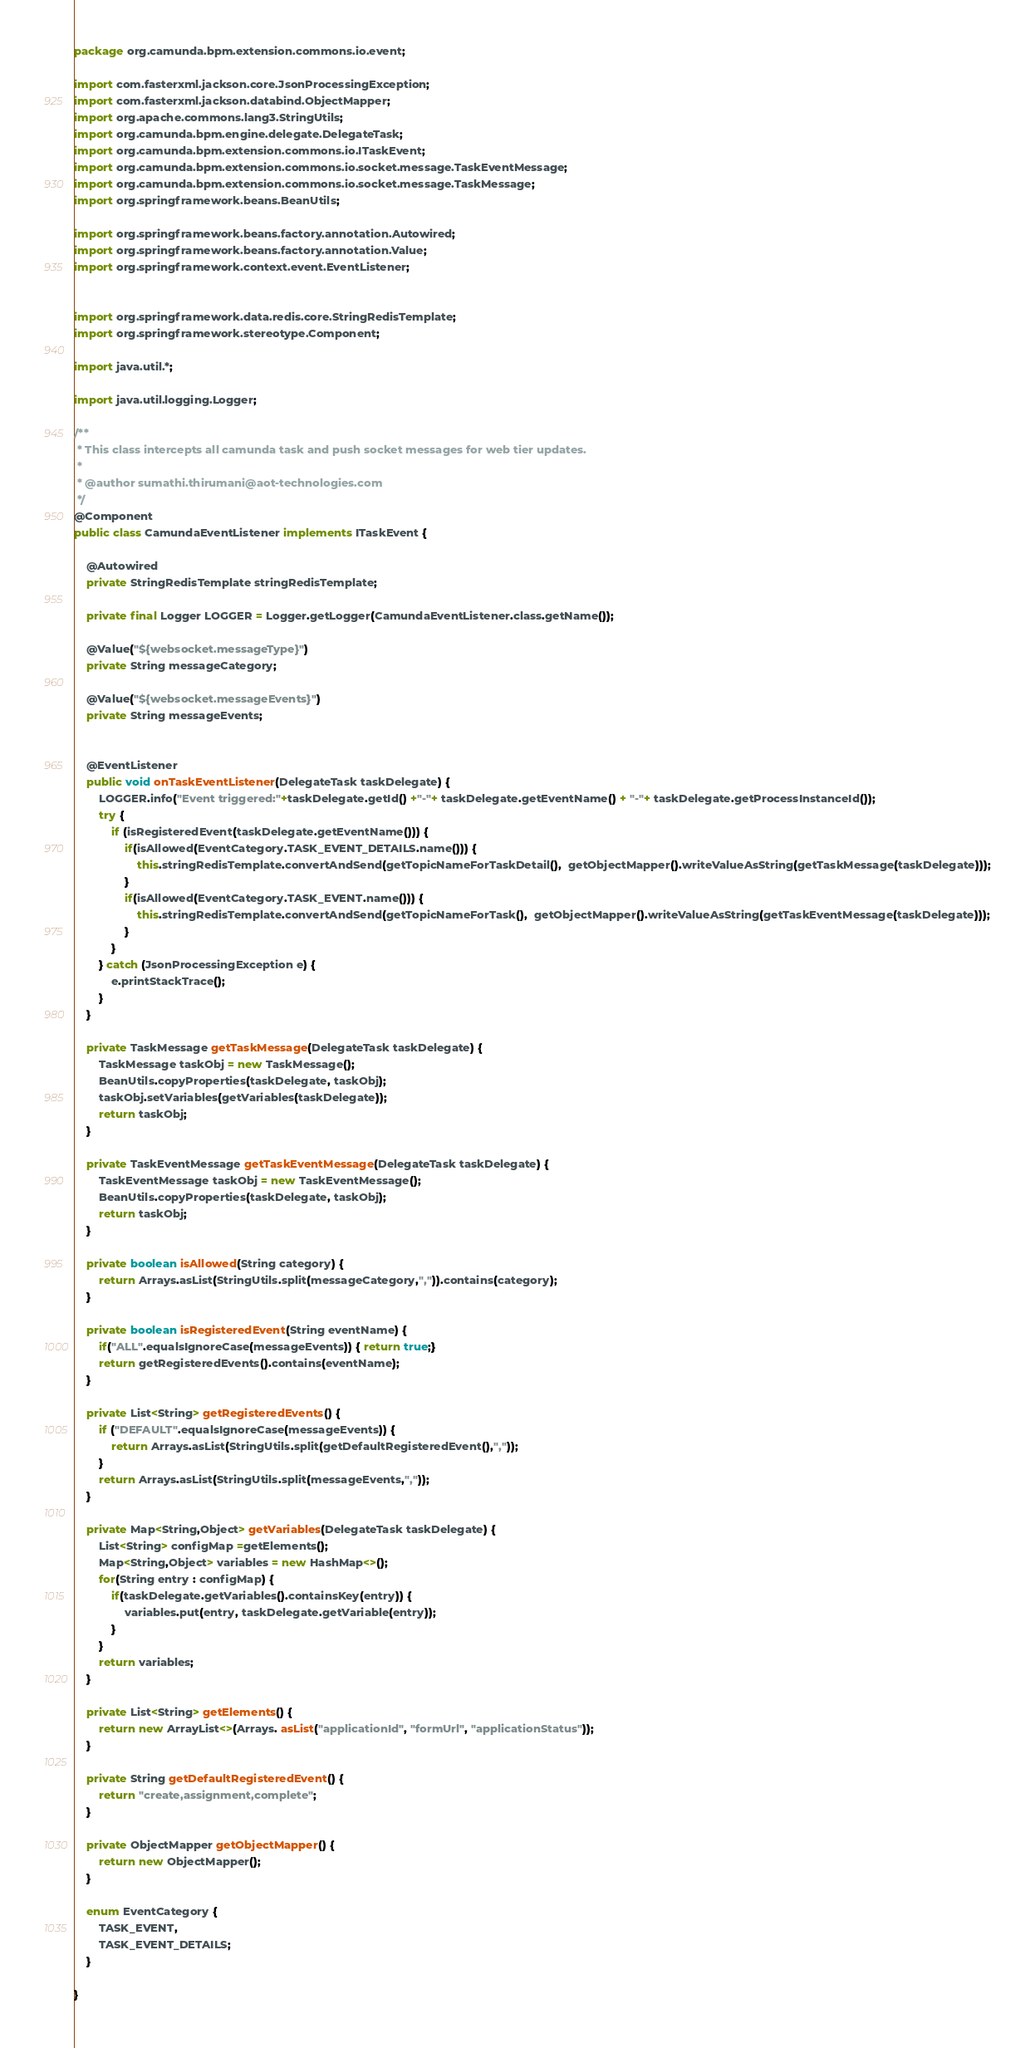<code> <loc_0><loc_0><loc_500><loc_500><_Java_>package org.camunda.bpm.extension.commons.io.event;

import com.fasterxml.jackson.core.JsonProcessingException;
import com.fasterxml.jackson.databind.ObjectMapper;
import org.apache.commons.lang3.StringUtils;
import org.camunda.bpm.engine.delegate.DelegateTask;
import org.camunda.bpm.extension.commons.io.ITaskEvent;
import org.camunda.bpm.extension.commons.io.socket.message.TaskEventMessage;
import org.camunda.bpm.extension.commons.io.socket.message.TaskMessage;
import org.springframework.beans.BeanUtils;

import org.springframework.beans.factory.annotation.Autowired;
import org.springframework.beans.factory.annotation.Value;
import org.springframework.context.event.EventListener;


import org.springframework.data.redis.core.StringRedisTemplate;
import org.springframework.stereotype.Component;

import java.util.*;

import java.util.logging.Logger;

/**
 * This class intercepts all camunda task and push socket messages for web tier updates.
 *
 * @author sumathi.thirumani@aot-technologies.com
 */
@Component
public class CamundaEventListener implements ITaskEvent {

    @Autowired
    private StringRedisTemplate stringRedisTemplate;

    private final Logger LOGGER = Logger.getLogger(CamundaEventListener.class.getName());

    @Value("${websocket.messageType}")
    private String messageCategory;
	
	@Value("${websocket.messageEvents}")
    private String messageEvents;


    @EventListener
    public void onTaskEventListener(DelegateTask taskDelegate) {
        LOGGER.info("Event triggered:"+taskDelegate.getId() +"-"+ taskDelegate.getEventName() + "-"+ taskDelegate.getProcessInstanceId());
        try {
			if (isRegisteredEvent(taskDelegate.getEventName())) {
				if(isAllowed(EventCategory.TASK_EVENT_DETAILS.name())) {
					this.stringRedisTemplate.convertAndSend(getTopicNameForTaskDetail(),  getObjectMapper().writeValueAsString(getTaskMessage(taskDelegate)));
				}
				if(isAllowed(EventCategory.TASK_EVENT.name())) {
					this.stringRedisTemplate.convertAndSend(getTopicNameForTask(),  getObjectMapper().writeValueAsString(getTaskEventMessage(taskDelegate)));
				}
			}
        } catch (JsonProcessingException e) {
            e.printStackTrace();
        }
    }

    private TaskMessage getTaskMessage(DelegateTask taskDelegate) {
        TaskMessage taskObj = new TaskMessage();
        BeanUtils.copyProperties(taskDelegate, taskObj);
        taskObj.setVariables(getVariables(taskDelegate));
        return taskObj;
    }

    private TaskEventMessage getTaskEventMessage(DelegateTask taskDelegate) {
        TaskEventMessage taskObj = new TaskEventMessage();
        BeanUtils.copyProperties(taskDelegate, taskObj);
        return taskObj;
    }

    private boolean isAllowed(String category) {
        return Arrays.asList(StringUtils.split(messageCategory,",")).contains(category);
    }
	
	private boolean isRegisteredEvent(String eventName) {
        if("ALL".equalsIgnoreCase(messageEvents)) { return true;}
        return getRegisteredEvents().contains(eventName);
    }

    private List<String> getRegisteredEvents() {
        if ("DEFAULT".equalsIgnoreCase(messageEvents)) {
            return Arrays.asList(StringUtils.split(getDefaultRegisteredEvent(),","));
        }
        return Arrays.asList(StringUtils.split(messageEvents,","));
    }

    private Map<String,Object> getVariables(DelegateTask taskDelegate) {
        List<String> configMap =getElements();
        Map<String,Object> variables = new HashMap<>();
        for(String entry : configMap) {
            if(taskDelegate.getVariables().containsKey(entry)) {
                variables.put(entry, taskDelegate.getVariable(entry));
            }
        }
        return variables;
    }

    private List<String> getElements() {
        return new ArrayList<>(Arrays. asList("applicationId", "formUrl", "applicationStatus"));
    }
	
	private String getDefaultRegisteredEvent() {
        return "create,assignment,complete";
    }

    private ObjectMapper getObjectMapper() {
        return new ObjectMapper();
    }

    enum EventCategory {
        TASK_EVENT,
        TASK_EVENT_DETAILS;
    }

}
</code> 